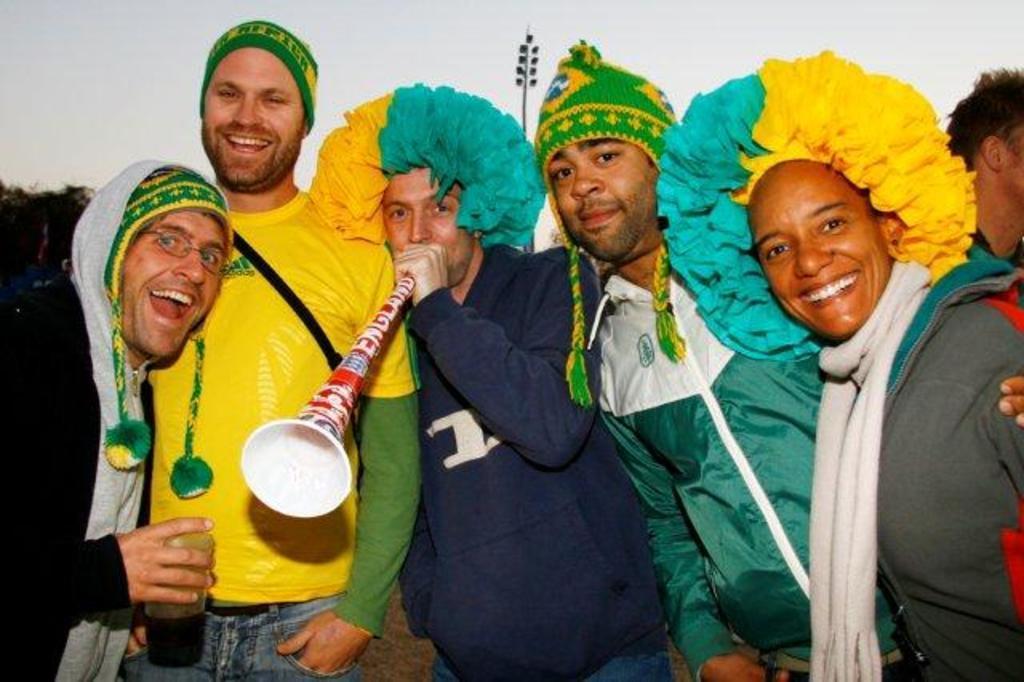In one or two sentences, can you explain what this image depicts? This picture is clicked outside. In the center there is a person wearing t-shirt, holding an object and standing and we can see the group of persons smiling and standing. In the background there is a sky and the trees. 